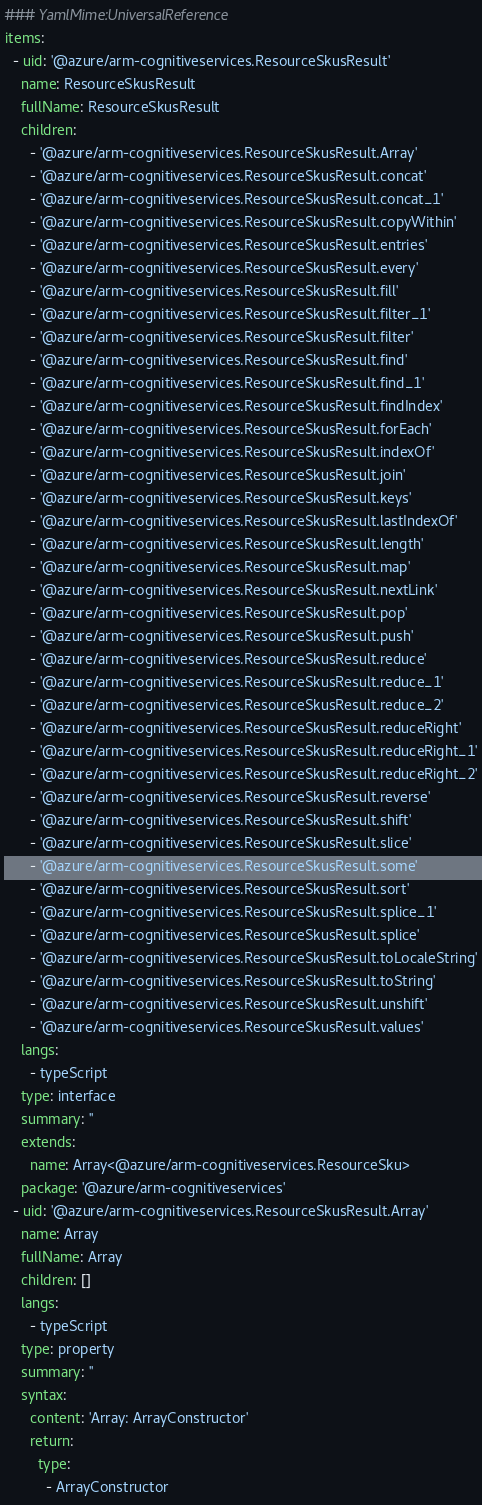<code> <loc_0><loc_0><loc_500><loc_500><_YAML_>### YamlMime:UniversalReference
items:
  - uid: '@azure/arm-cognitiveservices.ResourceSkusResult'
    name: ResourceSkusResult
    fullName: ResourceSkusResult
    children:
      - '@azure/arm-cognitiveservices.ResourceSkusResult.Array'
      - '@azure/arm-cognitiveservices.ResourceSkusResult.concat'
      - '@azure/arm-cognitiveservices.ResourceSkusResult.concat_1'
      - '@azure/arm-cognitiveservices.ResourceSkusResult.copyWithin'
      - '@azure/arm-cognitiveservices.ResourceSkusResult.entries'
      - '@azure/arm-cognitiveservices.ResourceSkusResult.every'
      - '@azure/arm-cognitiveservices.ResourceSkusResult.fill'
      - '@azure/arm-cognitiveservices.ResourceSkusResult.filter_1'
      - '@azure/arm-cognitiveservices.ResourceSkusResult.filter'
      - '@azure/arm-cognitiveservices.ResourceSkusResult.find'
      - '@azure/arm-cognitiveservices.ResourceSkusResult.find_1'
      - '@azure/arm-cognitiveservices.ResourceSkusResult.findIndex'
      - '@azure/arm-cognitiveservices.ResourceSkusResult.forEach'
      - '@azure/arm-cognitiveservices.ResourceSkusResult.indexOf'
      - '@azure/arm-cognitiveservices.ResourceSkusResult.join'
      - '@azure/arm-cognitiveservices.ResourceSkusResult.keys'
      - '@azure/arm-cognitiveservices.ResourceSkusResult.lastIndexOf'
      - '@azure/arm-cognitiveservices.ResourceSkusResult.length'
      - '@azure/arm-cognitiveservices.ResourceSkusResult.map'
      - '@azure/arm-cognitiveservices.ResourceSkusResult.nextLink'
      - '@azure/arm-cognitiveservices.ResourceSkusResult.pop'
      - '@azure/arm-cognitiveservices.ResourceSkusResult.push'
      - '@azure/arm-cognitiveservices.ResourceSkusResult.reduce'
      - '@azure/arm-cognitiveservices.ResourceSkusResult.reduce_1'
      - '@azure/arm-cognitiveservices.ResourceSkusResult.reduce_2'
      - '@azure/arm-cognitiveservices.ResourceSkusResult.reduceRight'
      - '@azure/arm-cognitiveservices.ResourceSkusResult.reduceRight_1'
      - '@azure/arm-cognitiveservices.ResourceSkusResult.reduceRight_2'
      - '@azure/arm-cognitiveservices.ResourceSkusResult.reverse'
      - '@azure/arm-cognitiveservices.ResourceSkusResult.shift'
      - '@azure/arm-cognitiveservices.ResourceSkusResult.slice'
      - '@azure/arm-cognitiveservices.ResourceSkusResult.some'
      - '@azure/arm-cognitiveservices.ResourceSkusResult.sort'
      - '@azure/arm-cognitiveservices.ResourceSkusResult.splice_1'
      - '@azure/arm-cognitiveservices.ResourceSkusResult.splice'
      - '@azure/arm-cognitiveservices.ResourceSkusResult.toLocaleString'
      - '@azure/arm-cognitiveservices.ResourceSkusResult.toString'
      - '@azure/arm-cognitiveservices.ResourceSkusResult.unshift'
      - '@azure/arm-cognitiveservices.ResourceSkusResult.values'
    langs:
      - typeScript
    type: interface
    summary: ''
    extends:
      name: Array<@azure/arm-cognitiveservices.ResourceSku>
    package: '@azure/arm-cognitiveservices'
  - uid: '@azure/arm-cognitiveservices.ResourceSkusResult.Array'
    name: Array
    fullName: Array
    children: []
    langs:
      - typeScript
    type: property
    summary: ''
    syntax:
      content: 'Array: ArrayConstructor'
      return:
        type:
          - ArrayConstructor</code> 